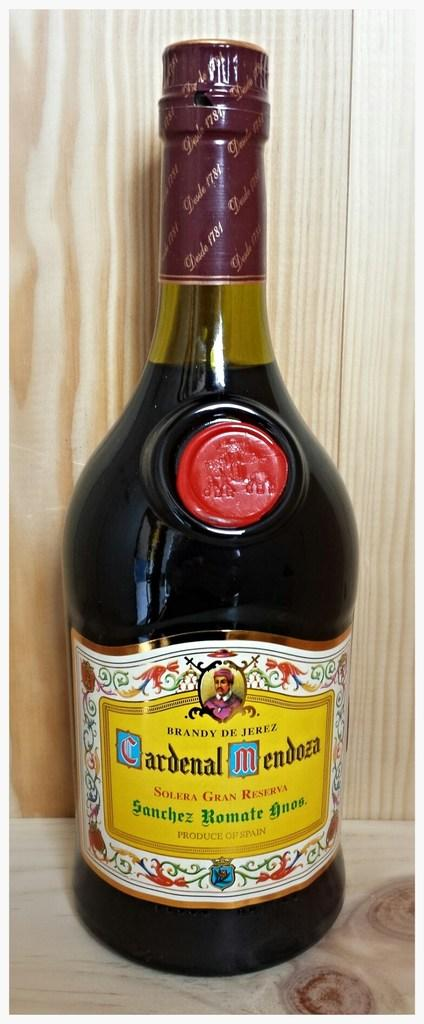Provide a one-sentence caption for the provided image. A bottle of Crdenal Mendoza Brandy sitting on a wood shelf. 